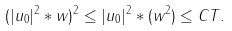Convert formula to latex. <formula><loc_0><loc_0><loc_500><loc_500>( | u _ { 0 } | ^ { 2 } * w ) ^ { 2 } \leq | u _ { 0 } | ^ { 2 } * ( w ^ { 2 } ) \leq C T .</formula> 